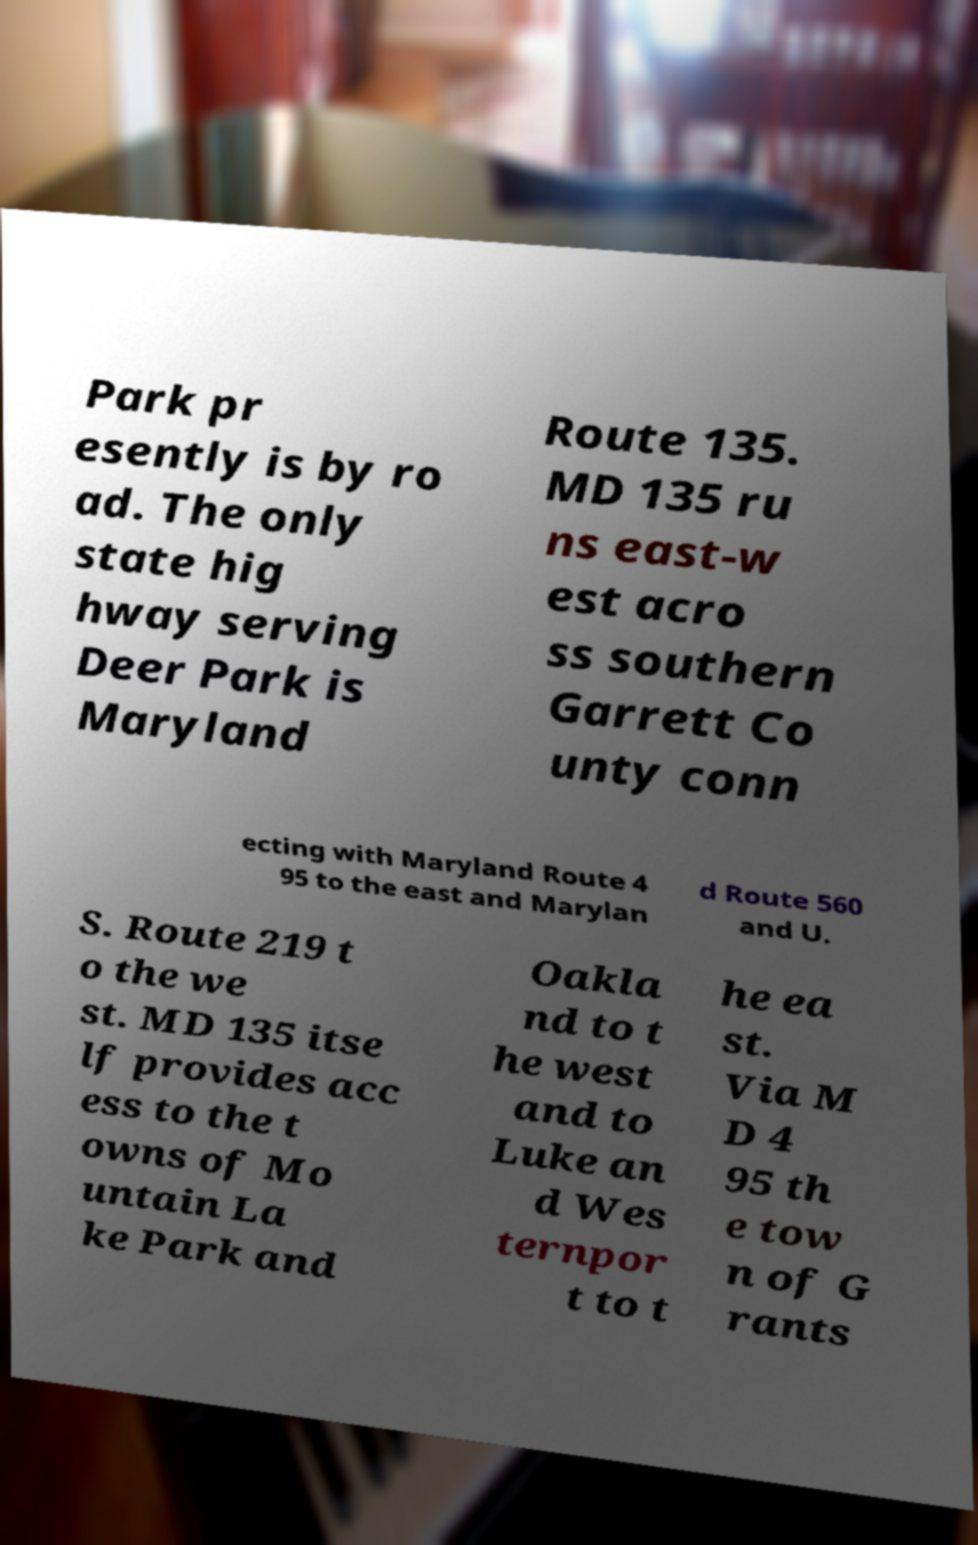Could you extract and type out the text from this image? Park pr esently is by ro ad. The only state hig hway serving Deer Park is Maryland Route 135. MD 135 ru ns east-w est acro ss southern Garrett Co unty conn ecting with Maryland Route 4 95 to the east and Marylan d Route 560 and U. S. Route 219 t o the we st. MD 135 itse lf provides acc ess to the t owns of Mo untain La ke Park and Oakla nd to t he west and to Luke an d Wes ternpor t to t he ea st. Via M D 4 95 th e tow n of G rants 